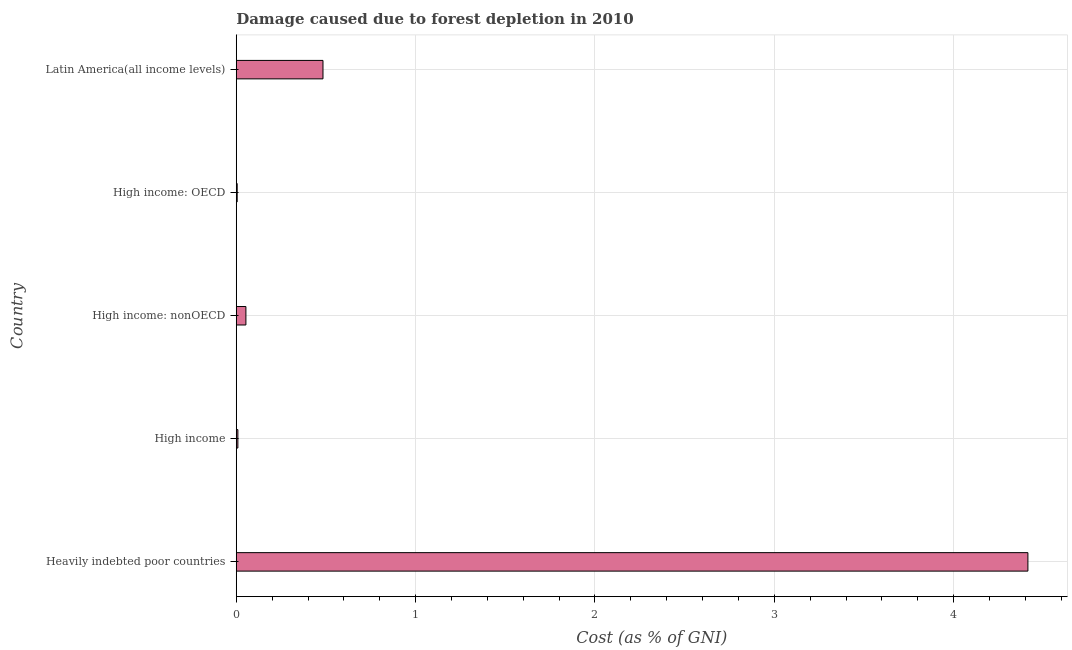Does the graph contain any zero values?
Your response must be concise. No. What is the title of the graph?
Ensure brevity in your answer.  Damage caused due to forest depletion in 2010. What is the label or title of the X-axis?
Ensure brevity in your answer.  Cost (as % of GNI). What is the label or title of the Y-axis?
Ensure brevity in your answer.  Country. What is the damage caused due to forest depletion in High income: nonOECD?
Provide a short and direct response. 0.05. Across all countries, what is the maximum damage caused due to forest depletion?
Offer a terse response. 4.41. Across all countries, what is the minimum damage caused due to forest depletion?
Provide a succinct answer. 0.01. In which country was the damage caused due to forest depletion maximum?
Your answer should be compact. Heavily indebted poor countries. In which country was the damage caused due to forest depletion minimum?
Provide a short and direct response. High income: OECD. What is the sum of the damage caused due to forest depletion?
Provide a short and direct response. 4.97. What is the difference between the damage caused due to forest depletion in High income and High income: OECD?
Ensure brevity in your answer.  0. What is the median damage caused due to forest depletion?
Offer a very short reply. 0.05. What is the ratio of the damage caused due to forest depletion in High income: OECD to that in Latin America(all income levels)?
Make the answer very short. 0.01. Is the difference between the damage caused due to forest depletion in High income and High income: nonOECD greater than the difference between any two countries?
Offer a terse response. No. What is the difference between the highest and the second highest damage caused due to forest depletion?
Make the answer very short. 3.93. Is the sum of the damage caused due to forest depletion in High income: nonOECD and Latin America(all income levels) greater than the maximum damage caused due to forest depletion across all countries?
Give a very brief answer. No. What is the difference between the highest and the lowest damage caused due to forest depletion?
Give a very brief answer. 4.41. In how many countries, is the damage caused due to forest depletion greater than the average damage caused due to forest depletion taken over all countries?
Your answer should be compact. 1. Are all the bars in the graph horizontal?
Give a very brief answer. Yes. How many countries are there in the graph?
Provide a short and direct response. 5. What is the Cost (as % of GNI) in Heavily indebted poor countries?
Make the answer very short. 4.41. What is the Cost (as % of GNI) of High income?
Your answer should be compact. 0.01. What is the Cost (as % of GNI) of High income: nonOECD?
Your response must be concise. 0.05. What is the Cost (as % of GNI) in High income: OECD?
Make the answer very short. 0.01. What is the Cost (as % of GNI) of Latin America(all income levels)?
Your answer should be very brief. 0.48. What is the difference between the Cost (as % of GNI) in Heavily indebted poor countries and High income?
Offer a very short reply. 4.4. What is the difference between the Cost (as % of GNI) in Heavily indebted poor countries and High income: nonOECD?
Offer a terse response. 4.36. What is the difference between the Cost (as % of GNI) in Heavily indebted poor countries and High income: OECD?
Your answer should be very brief. 4.41. What is the difference between the Cost (as % of GNI) in Heavily indebted poor countries and Latin America(all income levels)?
Your answer should be compact. 3.93. What is the difference between the Cost (as % of GNI) in High income and High income: nonOECD?
Keep it short and to the point. -0.04. What is the difference between the Cost (as % of GNI) in High income and High income: OECD?
Keep it short and to the point. 0. What is the difference between the Cost (as % of GNI) in High income and Latin America(all income levels)?
Give a very brief answer. -0.47. What is the difference between the Cost (as % of GNI) in High income: nonOECD and High income: OECD?
Provide a short and direct response. 0.05. What is the difference between the Cost (as % of GNI) in High income: nonOECD and Latin America(all income levels)?
Offer a terse response. -0.43. What is the difference between the Cost (as % of GNI) in High income: OECD and Latin America(all income levels)?
Your response must be concise. -0.48. What is the ratio of the Cost (as % of GNI) in Heavily indebted poor countries to that in High income?
Provide a succinct answer. 489.04. What is the ratio of the Cost (as % of GNI) in Heavily indebted poor countries to that in High income: nonOECD?
Offer a terse response. 82.05. What is the ratio of the Cost (as % of GNI) in Heavily indebted poor countries to that in High income: OECD?
Offer a very short reply. 851.75. What is the ratio of the Cost (as % of GNI) in Heavily indebted poor countries to that in Latin America(all income levels)?
Offer a very short reply. 9.13. What is the ratio of the Cost (as % of GNI) in High income to that in High income: nonOECD?
Your answer should be very brief. 0.17. What is the ratio of the Cost (as % of GNI) in High income to that in High income: OECD?
Give a very brief answer. 1.74. What is the ratio of the Cost (as % of GNI) in High income to that in Latin America(all income levels)?
Your answer should be very brief. 0.02. What is the ratio of the Cost (as % of GNI) in High income: nonOECD to that in High income: OECD?
Your answer should be compact. 10.38. What is the ratio of the Cost (as % of GNI) in High income: nonOECD to that in Latin America(all income levels)?
Make the answer very short. 0.11. What is the ratio of the Cost (as % of GNI) in High income: OECD to that in Latin America(all income levels)?
Your answer should be very brief. 0.01. 